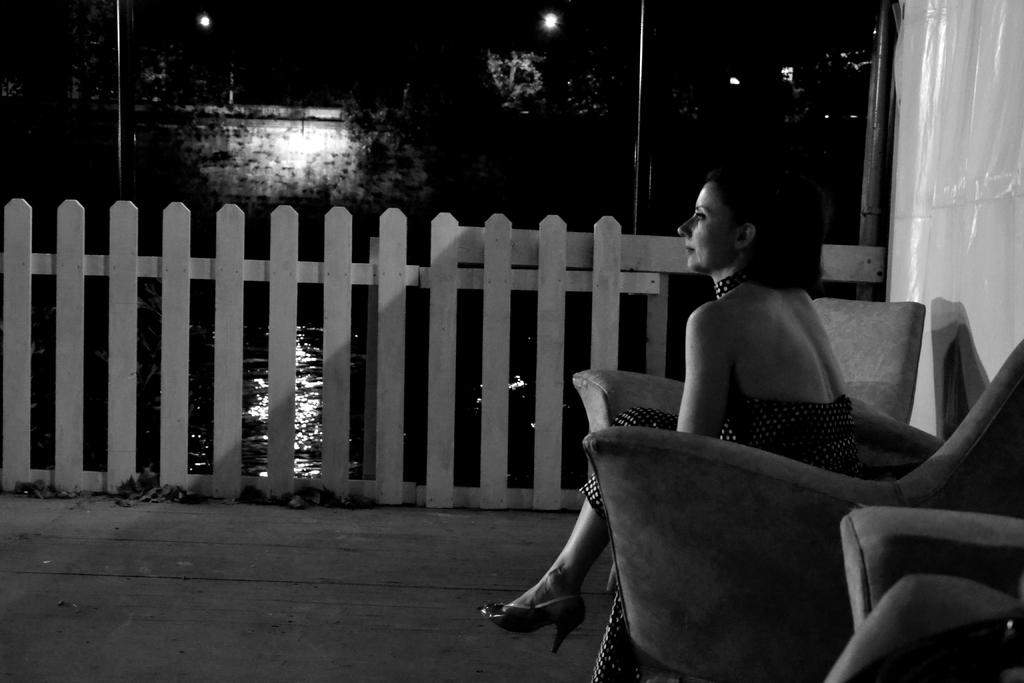What is the lady in the image doing? The lady is sitting on a sofa in the image. What is the lady looking at? The lady is staring at something in the image. What can be seen in the background of the image? Water, trees, and lights are visible in the background of the image. What type of picture is the lady holding in her knee in the image? There is no picture visible in the image, and the lady is not holding anything in her knee. 